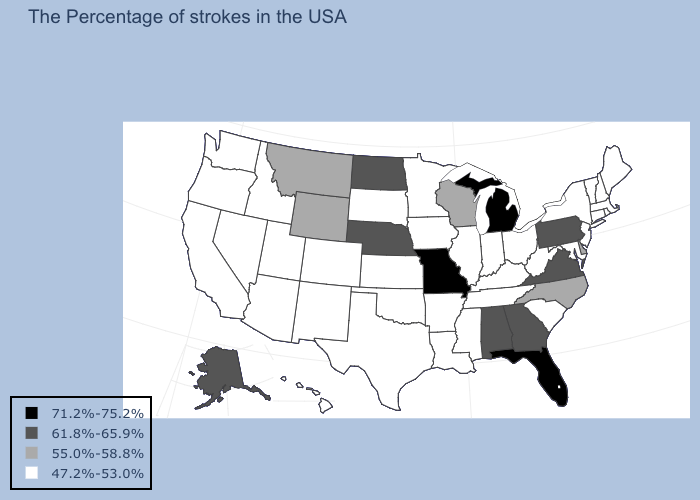What is the value of Pennsylvania?
Write a very short answer. 61.8%-65.9%. What is the value of Kansas?
Write a very short answer. 47.2%-53.0%. What is the value of Iowa?
Give a very brief answer. 47.2%-53.0%. Name the states that have a value in the range 55.0%-58.8%?
Keep it brief. Delaware, North Carolina, Wisconsin, Wyoming, Montana. Among the states that border New Hampshire , which have the highest value?
Concise answer only. Maine, Massachusetts, Vermont. Name the states that have a value in the range 47.2%-53.0%?
Be succinct. Maine, Massachusetts, Rhode Island, New Hampshire, Vermont, Connecticut, New York, New Jersey, Maryland, South Carolina, West Virginia, Ohio, Kentucky, Indiana, Tennessee, Illinois, Mississippi, Louisiana, Arkansas, Minnesota, Iowa, Kansas, Oklahoma, Texas, South Dakota, Colorado, New Mexico, Utah, Arizona, Idaho, Nevada, California, Washington, Oregon, Hawaii. What is the value of Maryland?
Short answer required. 47.2%-53.0%. Which states have the lowest value in the USA?
Quick response, please. Maine, Massachusetts, Rhode Island, New Hampshire, Vermont, Connecticut, New York, New Jersey, Maryland, South Carolina, West Virginia, Ohio, Kentucky, Indiana, Tennessee, Illinois, Mississippi, Louisiana, Arkansas, Minnesota, Iowa, Kansas, Oklahoma, Texas, South Dakota, Colorado, New Mexico, Utah, Arizona, Idaho, Nevada, California, Washington, Oregon, Hawaii. What is the value of Minnesota?
Short answer required. 47.2%-53.0%. Name the states that have a value in the range 71.2%-75.2%?
Keep it brief. Florida, Michigan, Missouri. How many symbols are there in the legend?
Write a very short answer. 4. What is the value of Tennessee?
Give a very brief answer. 47.2%-53.0%. Is the legend a continuous bar?
Write a very short answer. No. Among the states that border Michigan , which have the lowest value?
Short answer required. Ohio, Indiana. What is the value of Arkansas?
Concise answer only. 47.2%-53.0%. 